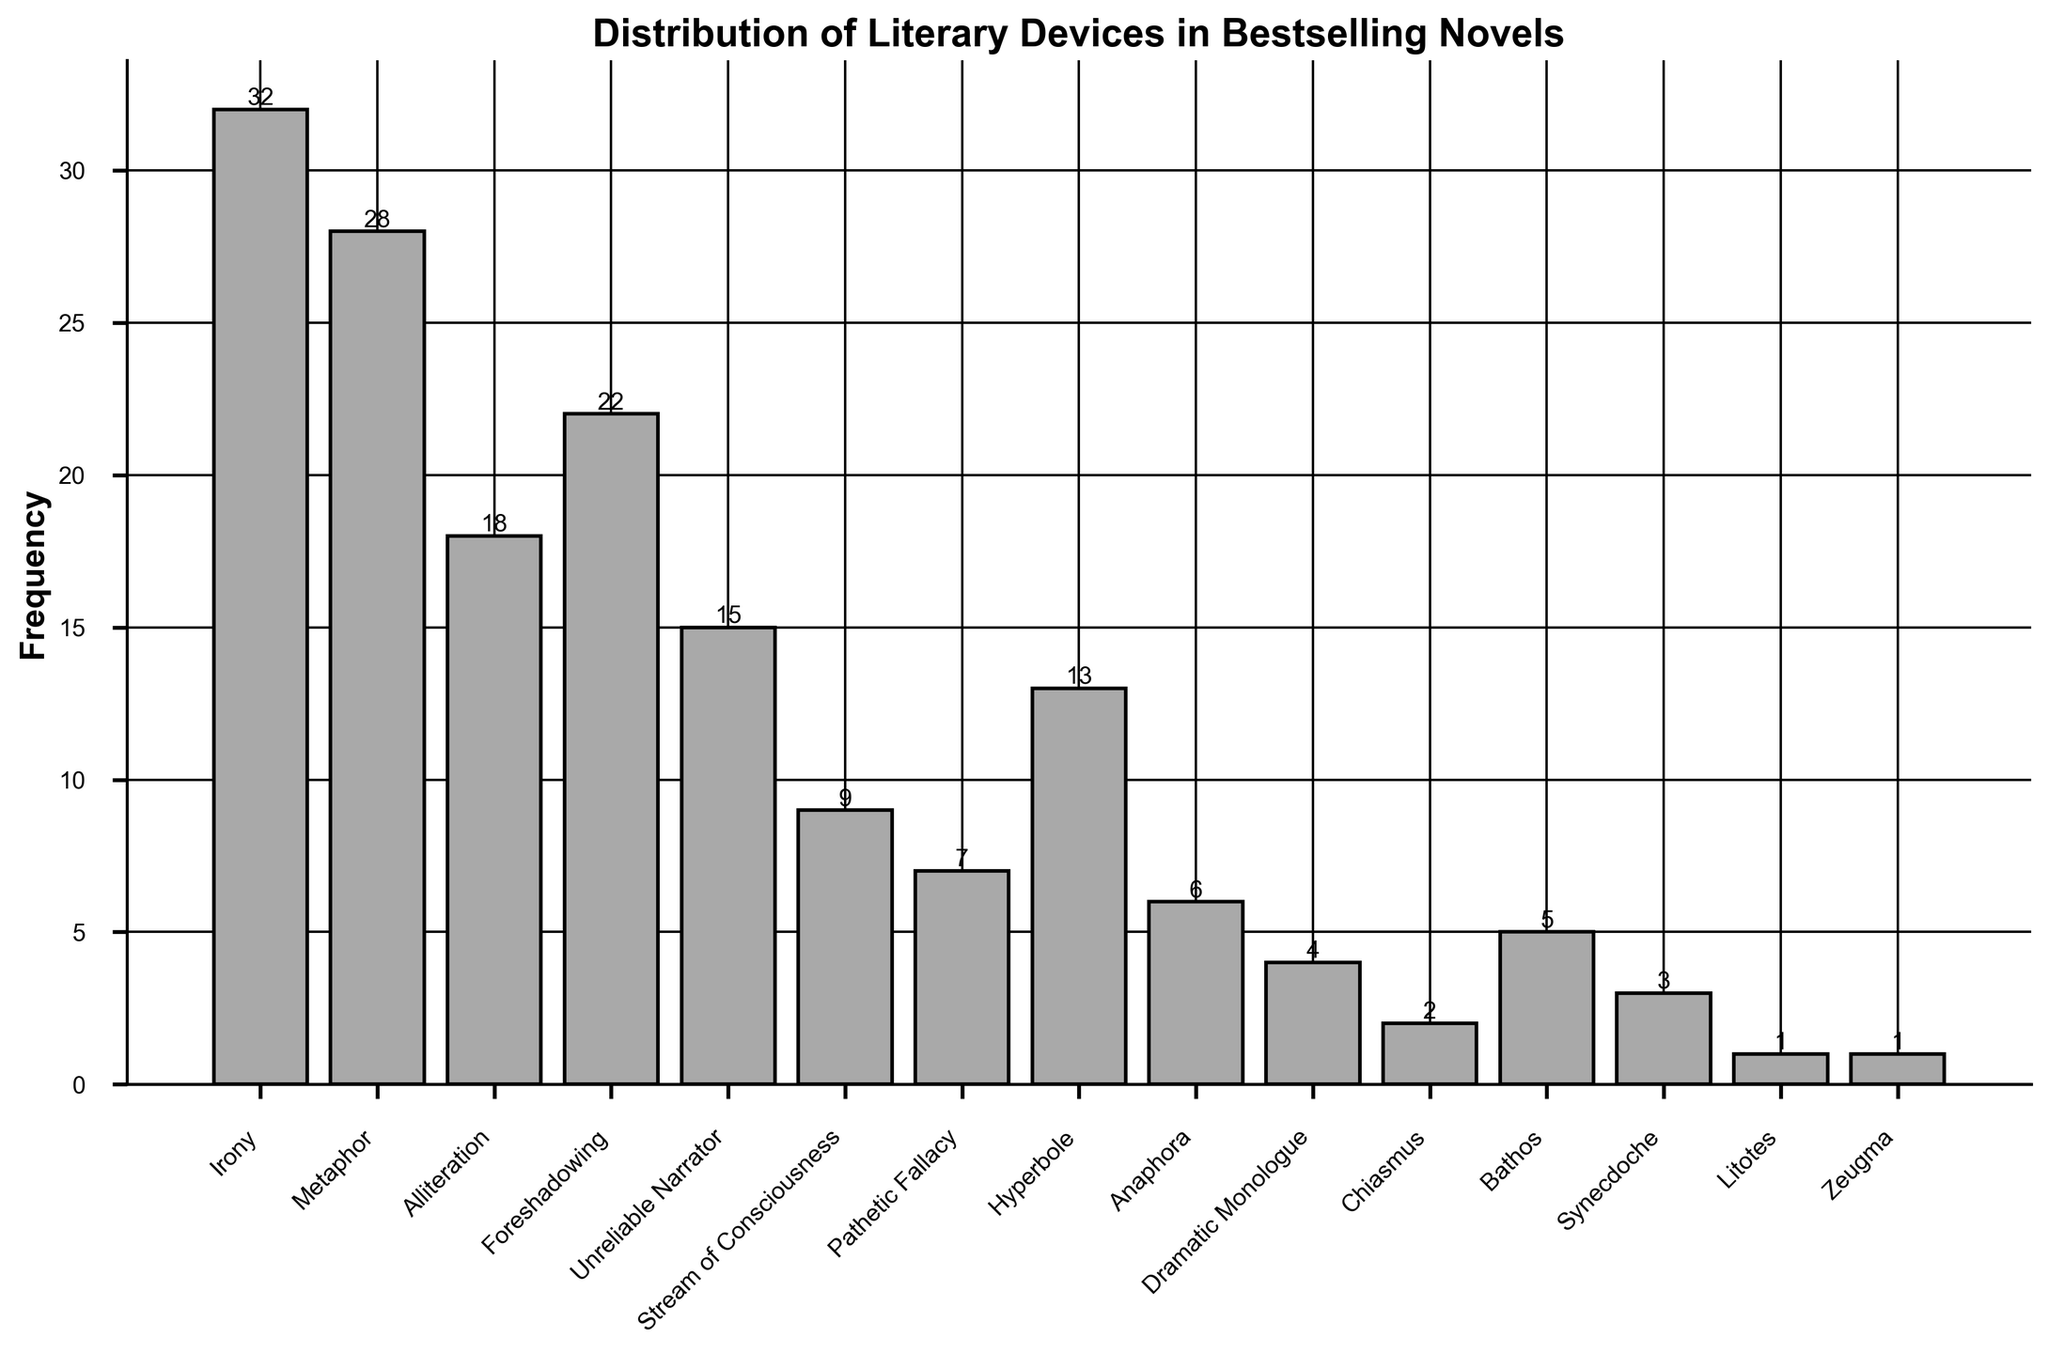What's the sum of frequencies for Irony, Metaphor, and Foreshadowing? Sum the frequencies of Irony (32), Metaphor (28), and Foreshadowing (22): 32 + 28 + 22 = 82
Answer: 82 Which literary device has the lowest frequency? Observe the heights of the bars; the lowest bar corresponds to a frequency of 1, which is for the literary devices Litotes and Zeugma.
Answer: Litotes and Zeugma How many more times is Irony used compared to Anaphora? Irony has a frequency of 32 and Anaphora has a frequency of 6. Subtract the lower frequency from the higher frequency: 32 - 6 = 26
Answer: 26 What's the average frequency of Hyperbole, Bathos, and Synecdoche? Sum the frequencies of Hyperbole (13), Bathos (5), and Synecdoche (3): 13 + 5 + 3 = 21. Divide by the number of items (3): 21 / 3 = 7
Answer: 7 Are there more literary devices with a frequency above 10 or below 10? Devices above 10: Irony, Metaphor, Alliteration, Foreshadowing, Unreliable Narrator, Hyperbole (6 devices); Devices below 10: Stream of Consciousness, Pathetic Fallacy, Anaphora, Dramatic Monologue, Chiasmus, Bathos, Synecdoche, Litotes, Zeugma (9 devices).
Answer: Below 10 Which literary device has the second-highest frequency? The highest frequency is Irony (32), followed by Metaphor with a frequency of 28.
Answer: Metaphor What's the difference in frequency between the most and least used literary devices? The highest frequency is 32 (Irony) and the lowest is 1 (Litotes, Zeugma). Subtract the lowest from the highest: 32 - 1 = 31
Answer: 31 Which literary devices have a frequency that's either equal to or less than 5? Observe the heights of the bars indicating frequencies equal to or less than 5: Bathos (5), Anaphora (6), Synecdoche (3), Dramatic Monologue (4), Chiasmus (2), Litotes (1), Zeugma (1). Removing Anaphora (6) leaves Bathos, Synecdoche, Dramatic Monologue, Chiasmus, Litotes, Zeugma.
Answer: Bathos, Synecdoche, Dramatic Monologue, Chiasmus, Litotes, Zeugma 